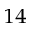<formula> <loc_0><loc_0><loc_500><loc_500>^ { 1 4 }</formula> 